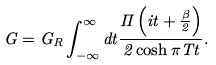<formula> <loc_0><loc_0><loc_500><loc_500>G = G _ { R } \int _ { - \infty } ^ { \infty } d t \frac { \Pi \left ( i t + \frac { \beta } { 2 } \right ) } { 2 \cosh \pi T t } .</formula> 